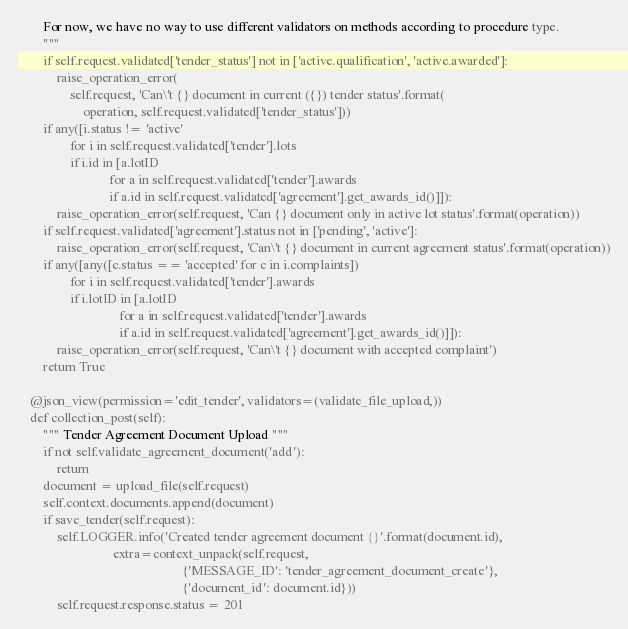Convert code to text. <code><loc_0><loc_0><loc_500><loc_500><_Python_>        For now, we have no way to use different validators on methods according to procedure type.
        """
        if self.request.validated['tender_status'] not in ['active.qualification', 'active.awarded']:
            raise_operation_error(
                self.request, 'Can\'t {} document in current ({}) tender status'.format(
                    operation, self.request.validated['tender_status']))
        if any([i.status != 'active'
                for i in self.request.validated['tender'].lots
                if i.id in [a.lotID
                            for a in self.request.validated['tender'].awards
                            if a.id in self.request.validated['agreement'].get_awards_id()]]):
            raise_operation_error(self.request, 'Can {} document only in active lot status'.format(operation))
        if self.request.validated['agreement'].status not in ['pending', 'active']:
            raise_operation_error(self.request, 'Can\'t {} document in current agreement status'.format(operation))
        if any([any([c.status == 'accepted' for c in i.complaints])
                for i in self.request.validated['tender'].awards
                if i.lotID in [a.lotID
                               for a in self.request.validated['tender'].awards
                               if a.id in self.request.validated['agreement'].get_awards_id()]]):
            raise_operation_error(self.request, 'Can\'t {} document with accepted complaint')
        return True

    @json_view(permission='edit_tender', validators=(validate_file_upload,))
    def collection_post(self):
        """ Tender Agreement Document Upload """
        if not self.validate_agreement_document('add'):
            return
        document = upload_file(self.request)
        self.context.documents.append(document)
        if save_tender(self.request):
            self.LOGGER.info('Created tender agreement document {}'.format(document.id),
                             extra=context_unpack(self.request,
                                                  {'MESSAGE_ID': 'tender_agreement_document_create'},
                                                  {'document_id': document.id}))
            self.request.response.status = 201</code> 